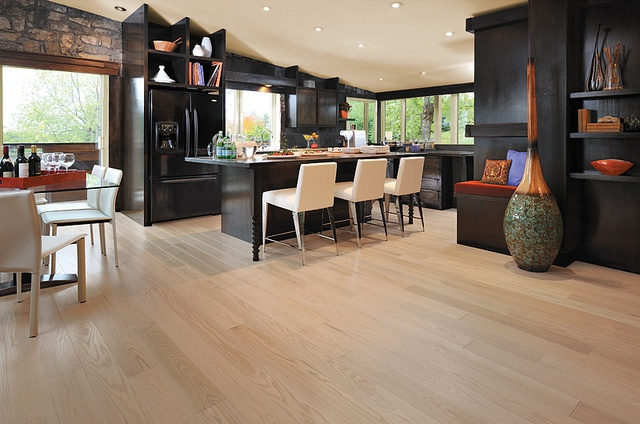Describe the objects in this image and their specific colors. I can see refrigerator in black and gray tones, dining table in black, gray, lightgray, and darkgray tones, chair in black, gray, and lightgray tones, chair in black, tan, and lightgray tones, and dining table in black, maroon, lightgray, and darkgray tones in this image. 